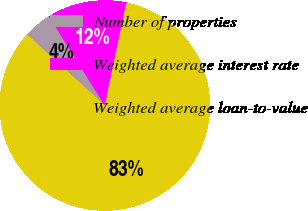Convert chart to OTSL. <chart><loc_0><loc_0><loc_500><loc_500><pie_chart><fcel>Number of properties<fcel>Weighted average interest rate<fcel>Weighted average loan-to-value<nl><fcel>4.3%<fcel>12.22%<fcel>83.49%<nl></chart> 